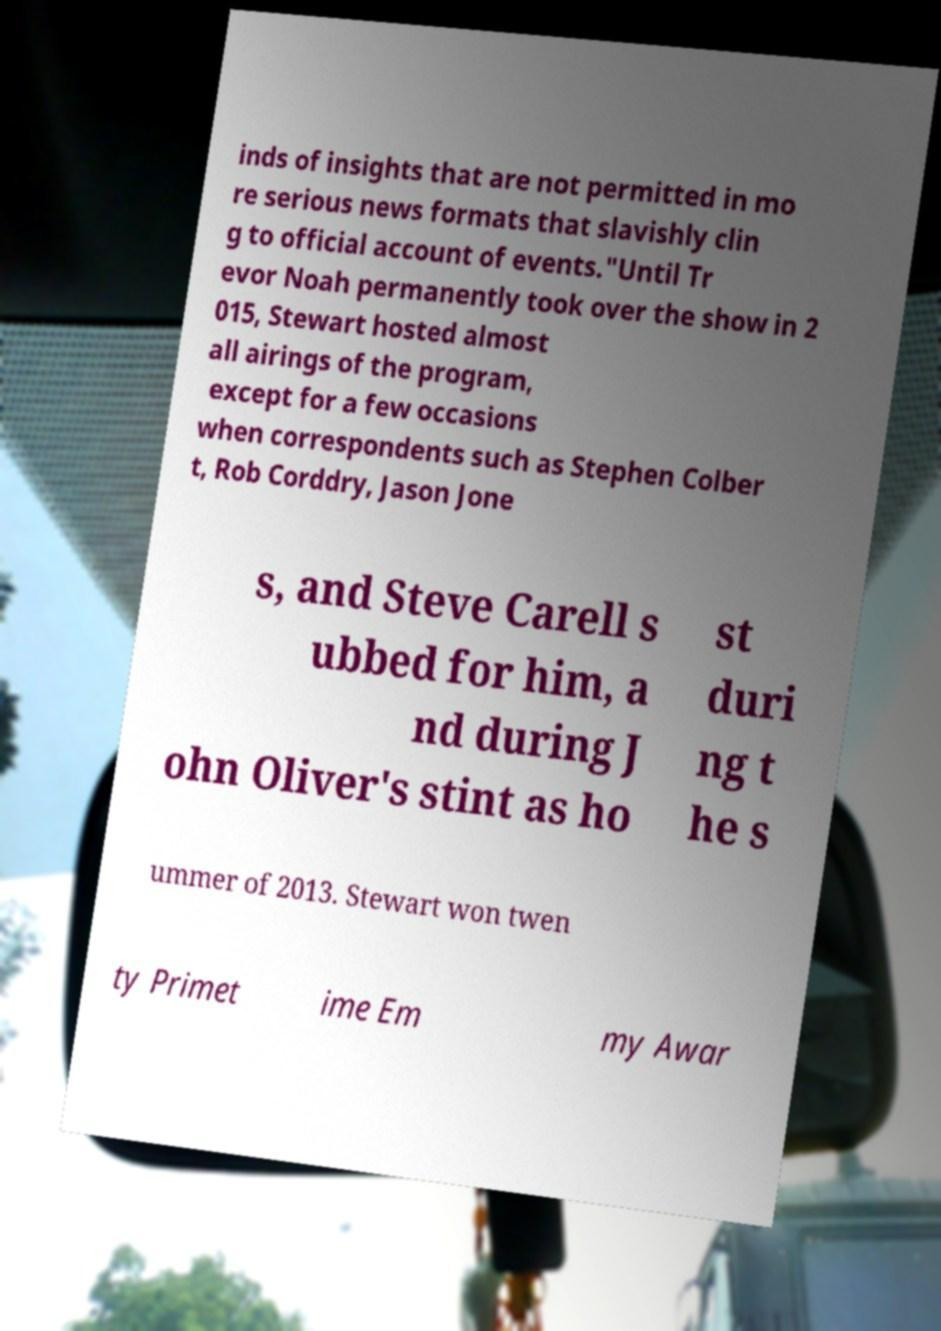Can you accurately transcribe the text from the provided image for me? inds of insights that are not permitted in mo re serious news formats that slavishly clin g to official account of events."Until Tr evor Noah permanently took over the show in 2 015, Stewart hosted almost all airings of the program, except for a few occasions when correspondents such as Stephen Colber t, Rob Corddry, Jason Jone s, and Steve Carell s ubbed for him, a nd during J ohn Oliver's stint as ho st duri ng t he s ummer of 2013. Stewart won twen ty Primet ime Em my Awar 